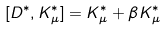<formula> <loc_0><loc_0><loc_500><loc_500>[ D ^ { \ast } , K _ { \mu } ^ { \ast } ] = K _ { \mu } ^ { \ast } + \beta K _ { \mu } ^ { \ast }</formula> 